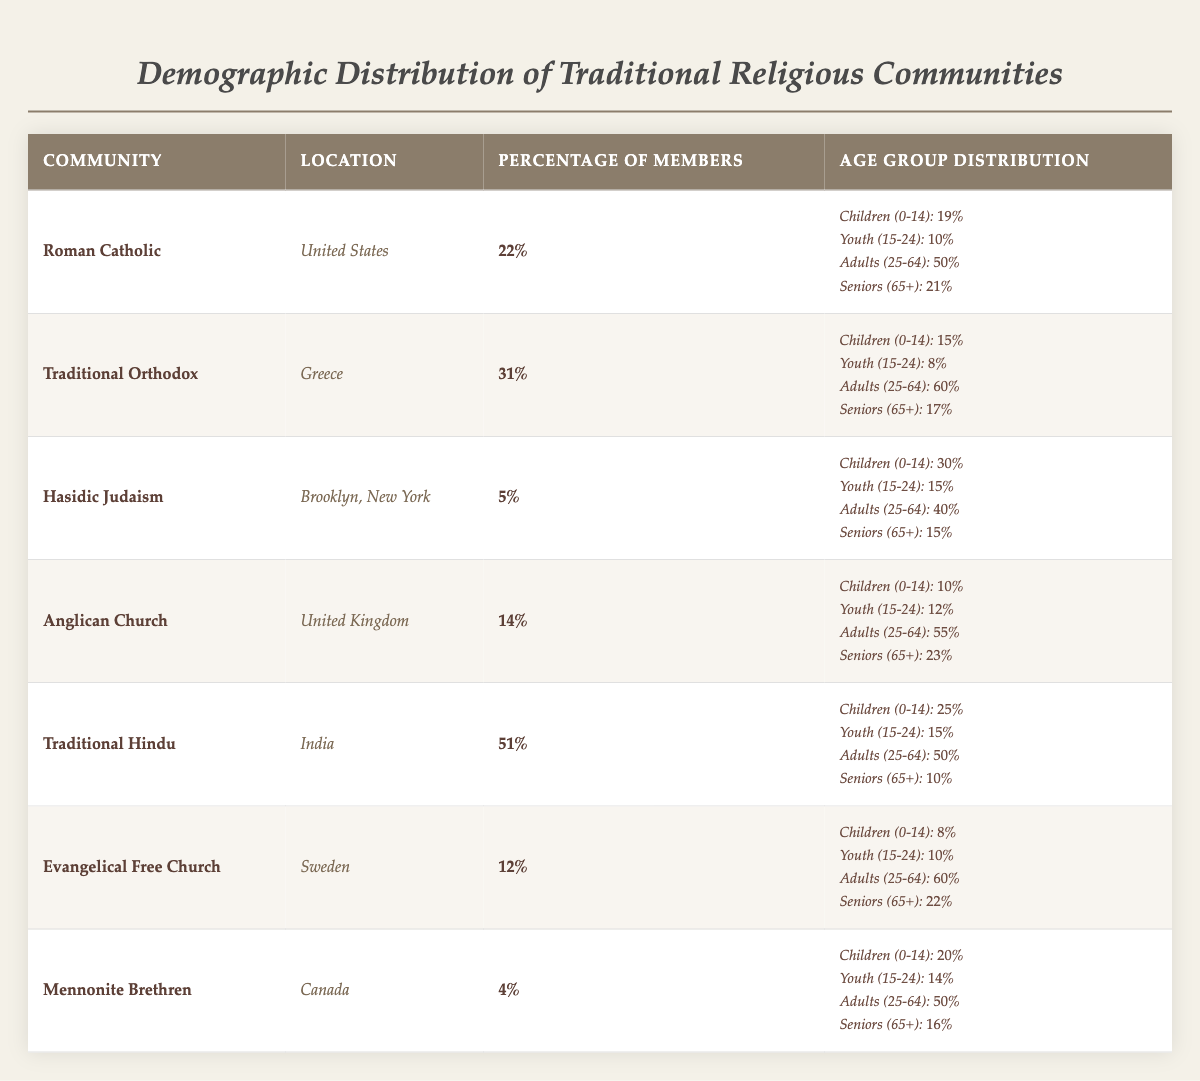What percentage of members belong to the Traditional Hindu community? The table shows that the Traditional Hindu community has 51% of members listed in the percentage column.
Answer: 51% Which community has the highest percentage of members? By comparing the percentages in the table, Traditional Hindu has the highest percentage at 51%.
Answer: Traditional Hindu What is the age group percentage of Seniors (65+) in the Anglican Church? Looking at the age group distribution for the Anglican Church in the fourth row, the percentage for Seniors (65+) is 23%.
Answer: 23% Calculate the average percentage of Children (0-14) across all communities. The percentages for Children (0-14) are 19, 15, 30, 10, 25, 8, and 20. Summing these values gives 127. There are 7 communities, so the average is 127/7 ≈ 18.14.
Answer: 18.14% Is it true that Hasidic Judaism has a higher percentage of Youth (15-24) compared to Traditional Orthodox? Looking at the data, Hasidic Judaism has 15% in the Youth (15-24) category while Traditional Orthodox has 8%. Thus, it is true.
Answer: Yes What is the difference in percentage of adults (25-64) between the Evangelical Free Church and the Mennonite Brethren? The percentage of Adults (25-64) for Evangelical Free Church is 60% and for Mennonite Brethren is 50%. The difference is 60 - 50 = 10%.
Answer: 10% Which community has the lowest percentage of members? By examining the percentage column, the Mennonite Brethren community shows the lowest percentage of 4%.
Answer: Mennonite Brethren What is the total percentage of Seniors (65+) for the Roman Catholic and Anglican Church combined? The Roman Catholic percentage for Seniors (65+) is 21% and the Anglican Church is 23%. Adding these gives 21 + 23 = 44%.
Answer: 44% How many communities have more than 20% of members aged 25-64? Upon checking the ages for the adults (25-64), only Roman Catholic (50%), Traditional Orthodox (60%), Anglican Church (55%), and Traditional Hindu (50%) have over 20%. This amounts to four communities.
Answer: 4 Is the percentage of Children (0-14) greater in the Hasidic Judaism community compared to the Evangelical Free Church? Hasidic Judaism has 30% for Children (0-14), whereas the Evangelical Free Church has 8%. Therefore, the statement is true that Hasidic Judaism has a higher percentage.
Answer: Yes What is the total percentage of members for communities located outside the United States? The communities located outside the United States are Traditional Orthodox (31%), Hasidic Judaism (5%), Traditional Hindu (51%), Evangelical Free Church (12%), and Mennonite Brethren (4%). The total percentage is 31 + 5 + 51 + 12 + 4 = 103%.
Answer: 103% 